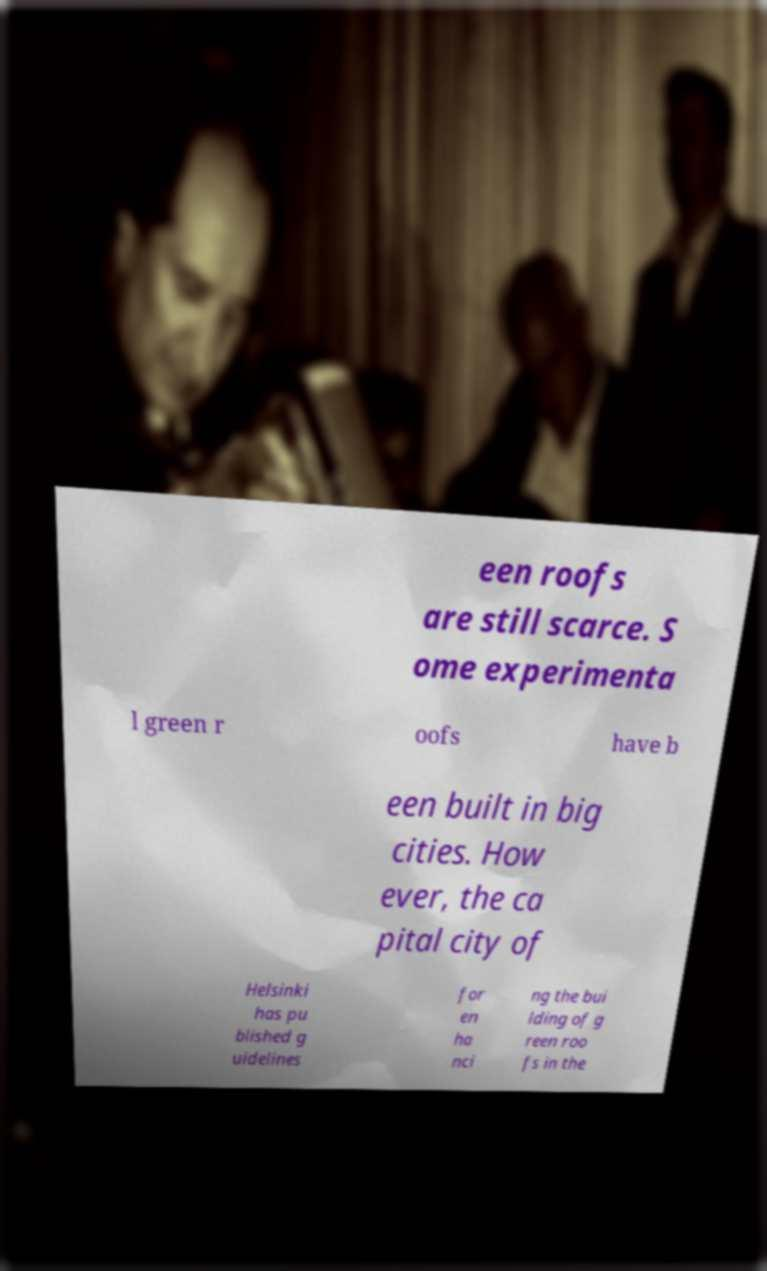Please read and relay the text visible in this image. What does it say? een roofs are still scarce. S ome experimenta l green r oofs have b een built in big cities. How ever, the ca pital city of Helsinki has pu blished g uidelines for en ha nci ng the bui lding of g reen roo fs in the 